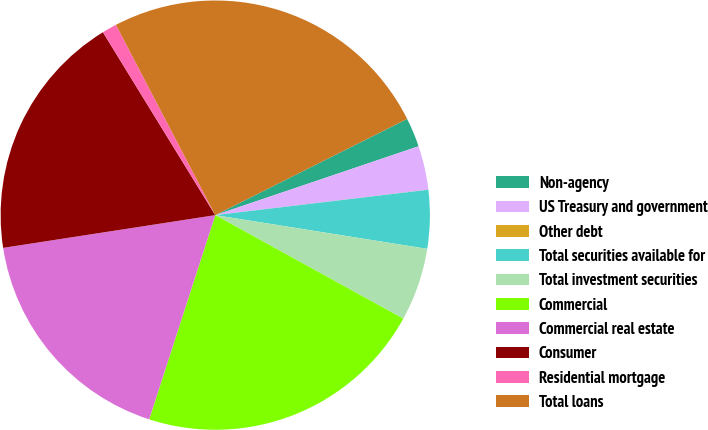Convert chart to OTSL. <chart><loc_0><loc_0><loc_500><loc_500><pie_chart><fcel>Non-agency<fcel>US Treasury and government<fcel>Other debt<fcel>Total securities available for<fcel>Total investment securities<fcel>Commercial<fcel>Commercial real estate<fcel>Consumer<fcel>Residential mortgage<fcel>Total loans<nl><fcel>2.2%<fcel>3.3%<fcel>0.01%<fcel>4.4%<fcel>5.5%<fcel>21.97%<fcel>17.58%<fcel>18.67%<fcel>1.11%<fcel>25.26%<nl></chart> 